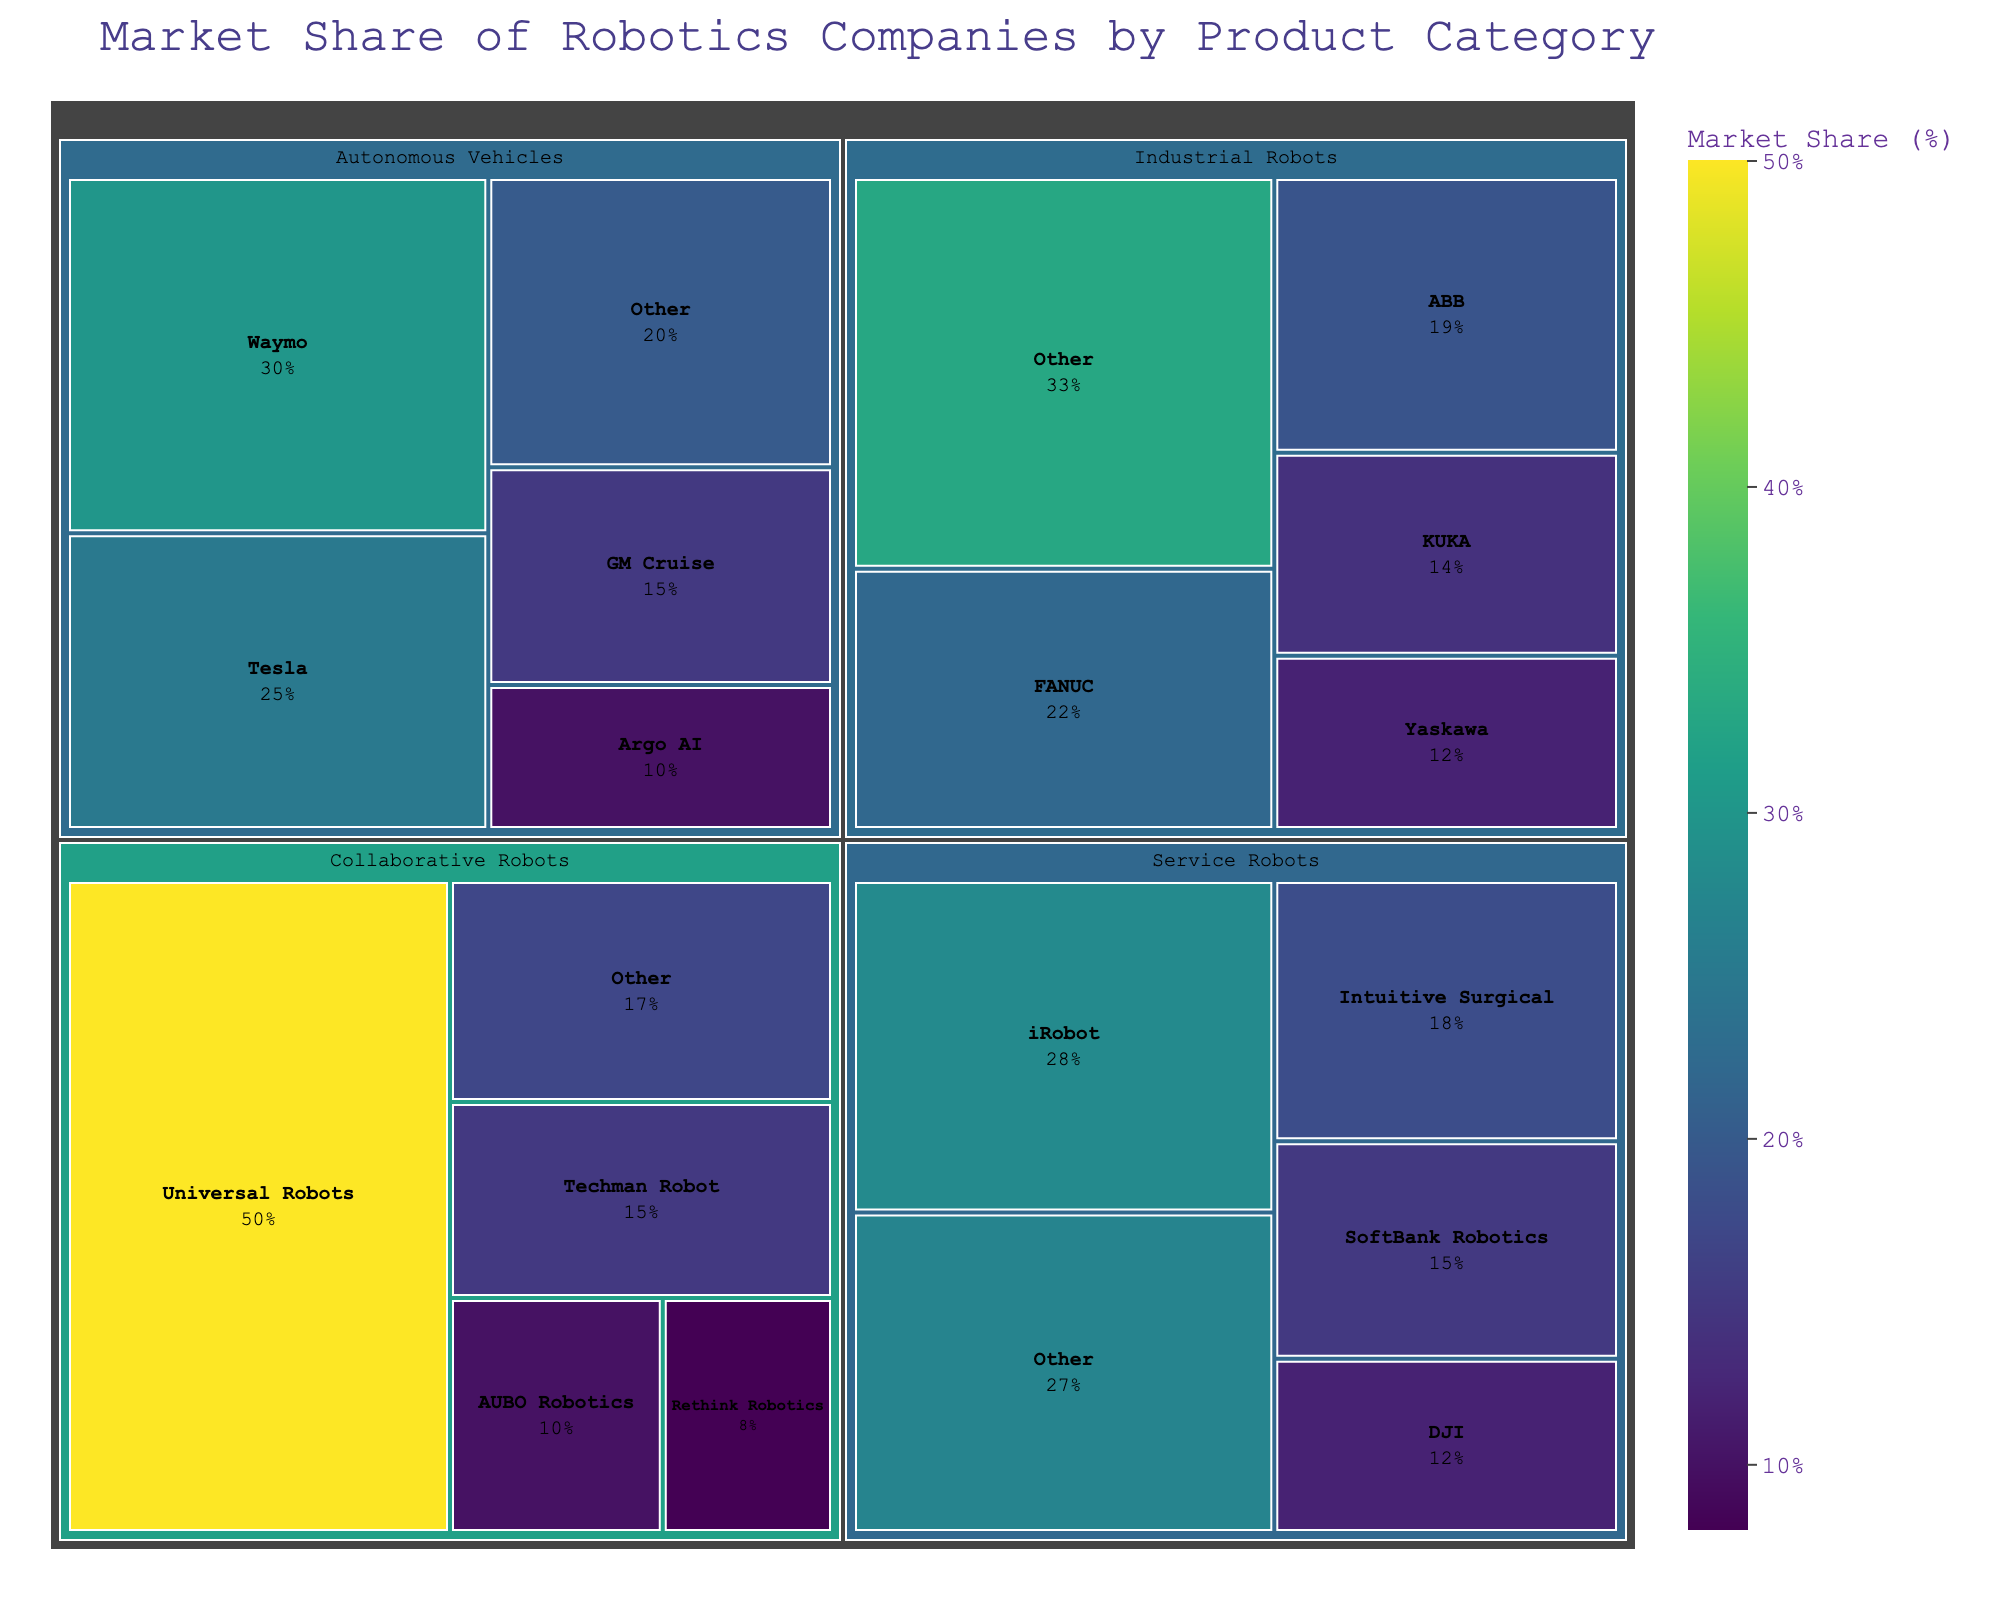What is the title of the figure? The title of the figure is displayed at the top, summarizing its content.
Answer: Market Share of Robotics Companies by Product Category Which company has the largest market share in the Service Robots category? Look within the Service Robots section and identify the company with the largest market share value.
Answer: iRobot How does Waymo's market share in Autonomous Vehicles compare to Tesla's? Compare the market share percentage of Waymo and Tesla in the Autonomous Vehicles section.
Answer: Waymo has a larger market share (30% vs. 25%) What is the combined market share of FANUC and ABB in Industrial Robots? Add the market shares of FANUC (22%) and ABB (19%) in the Industrial Robots section.
Answer: 41% Which category has the smallest "Other" market share component? Look at each category and determine the "Other" market share value, finding the smallest one.
Answer: Collaborative Robots (17%) What is the difference in market share between DJI and SoftBank Robotics in the Service Robots category? Subtract DJI's market share (12%) from SoftBank Robotics' market share (15%) in the Service Robots section.
Answer: 3% In which category does the company Universal Robots have a market share, and what is that share? Identify the category in which Universal Robots is listed and note the market share.
Answer: Collaborative Robots, 50% How many companies are listed in the Autonomous Vehicles category? Count the number of individual companies (excluding "Other") in the Autonomous Vehicles section.
Answer: 4 Which category has the highest representation of companies excluding "Other"? Count the number of companies (excluding "Other") for each category and identify the highest.
Answer: Industrial Robots (4 companies) Compare the market share of GM Cruise and Tesla in Autonomous Vehicles; by how much does Tesla exceed GM Cruise? Subtract GM Cruise's market share (15%) from Tesla's market share (25%) in the Autonomous Vehicles section.
Answer: 10% Based on the color representation, which company in the Industrial Robots category has the highest market share? Identify the company with the darkest color shade in the Industrial Robots section, indicating the highest market share.
Answer: FANUC 